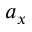<formula> <loc_0><loc_0><loc_500><loc_500>a _ { x }</formula> 